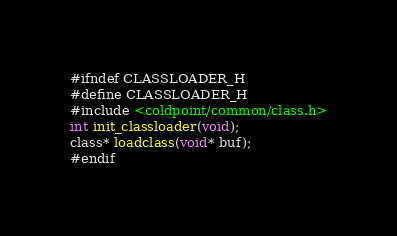Convert code to text. <code><loc_0><loc_0><loc_500><loc_500><_C_>#ifndef CLASSLOADER_H
#define CLASSLOADER_H
#include <coldpoint/common/class.h>
int init_classloader(void);
class* loadclass(void* buf);
#endif
</code> 